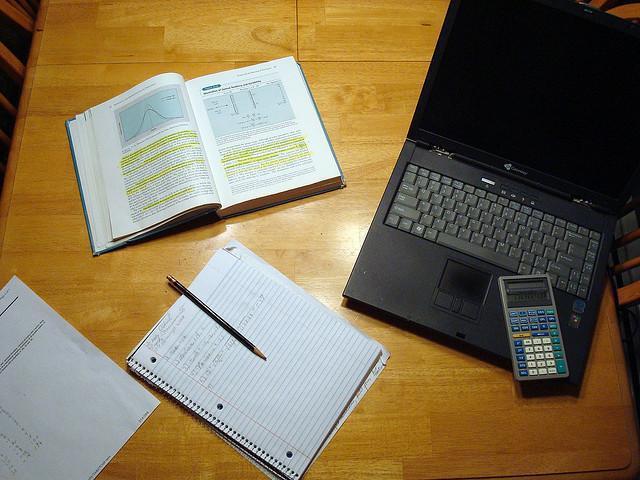How many books are visible?
Give a very brief answer. 2. 